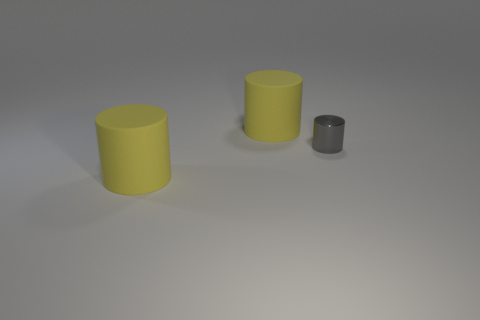Could you describe the lighting and shadows in the image? The image features a soft, diffused light source coming from the top left, casting gentle shadows to the right of the cylinders. The shadow lengths vary according to the size of the cylinders, with the smallest cylinder casting a shorter shadow. The lighting creates a calm, understated mood and visually indicates the three-dimensionality of the objects. 